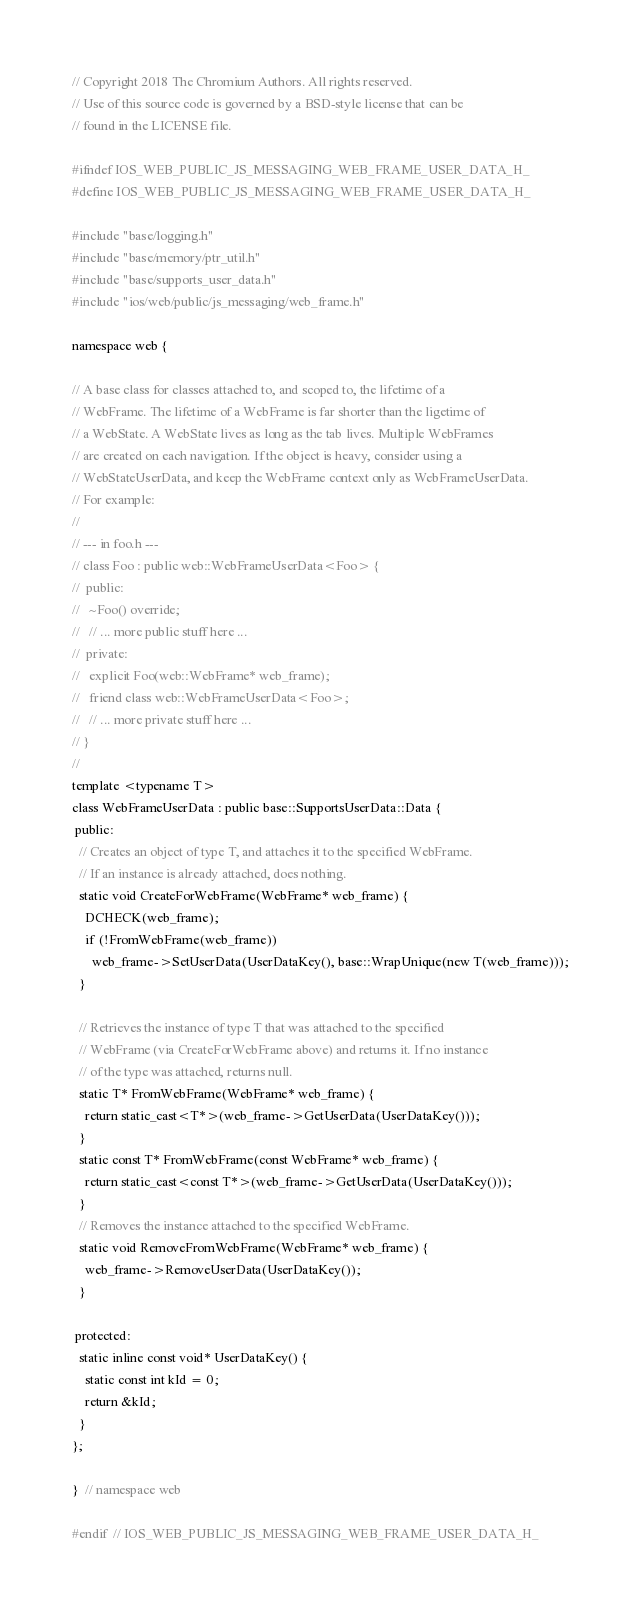Convert code to text. <code><loc_0><loc_0><loc_500><loc_500><_C_>// Copyright 2018 The Chromium Authors. All rights reserved.
// Use of this source code is governed by a BSD-style license that can be
// found in the LICENSE file.

#ifndef IOS_WEB_PUBLIC_JS_MESSAGING_WEB_FRAME_USER_DATA_H_
#define IOS_WEB_PUBLIC_JS_MESSAGING_WEB_FRAME_USER_DATA_H_

#include "base/logging.h"
#include "base/memory/ptr_util.h"
#include "base/supports_user_data.h"
#include "ios/web/public/js_messaging/web_frame.h"

namespace web {

// A base class for classes attached to, and scoped to, the lifetime of a
// WebFrame. The lifetime of a WebFrame is far shorter than the ligetime of
// a WebState. A WebState lives as long as the tab lives. Multiple WebFrames
// are created on each navigation. If the object is heavy, consider using a
// WebStateUserData, and keep the WebFrame context only as WebFrameUserData.
// For example:
//
// --- in foo.h ---
// class Foo : public web::WebFrameUserData<Foo> {
//  public:
//   ~Foo() override;
//   // ... more public stuff here ...
//  private:
//   explicit Foo(web::WebFrame* web_frame);
//   friend class web::WebFrameUserData<Foo>;
//   // ... more private stuff here ...
// }
//
template <typename T>
class WebFrameUserData : public base::SupportsUserData::Data {
 public:
  // Creates an object of type T, and attaches it to the specified WebFrame.
  // If an instance is already attached, does nothing.
  static void CreateForWebFrame(WebFrame* web_frame) {
    DCHECK(web_frame);
    if (!FromWebFrame(web_frame))
      web_frame->SetUserData(UserDataKey(), base::WrapUnique(new T(web_frame)));
  }

  // Retrieves the instance of type T that was attached to the specified
  // WebFrame (via CreateForWebFrame above) and returns it. If no instance
  // of the type was attached, returns null.
  static T* FromWebFrame(WebFrame* web_frame) {
    return static_cast<T*>(web_frame->GetUserData(UserDataKey()));
  }
  static const T* FromWebFrame(const WebFrame* web_frame) {
    return static_cast<const T*>(web_frame->GetUserData(UserDataKey()));
  }
  // Removes the instance attached to the specified WebFrame.
  static void RemoveFromWebFrame(WebFrame* web_frame) {
    web_frame->RemoveUserData(UserDataKey());
  }

 protected:
  static inline const void* UserDataKey() {
    static const int kId = 0;
    return &kId;
  }
};

}  // namespace web

#endif  // IOS_WEB_PUBLIC_JS_MESSAGING_WEB_FRAME_USER_DATA_H_
</code> 